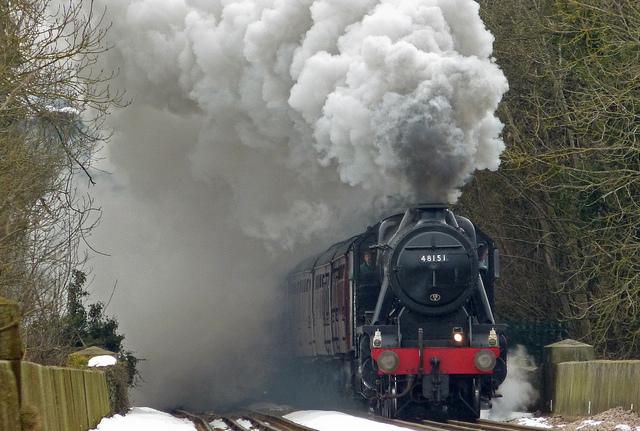What colors make up the train's paint?
Give a very brief answer. Black and red. Could Sabin suplex this train?
Write a very short answer. Yes. Is this a steam engine?
Give a very brief answer. Yes. 